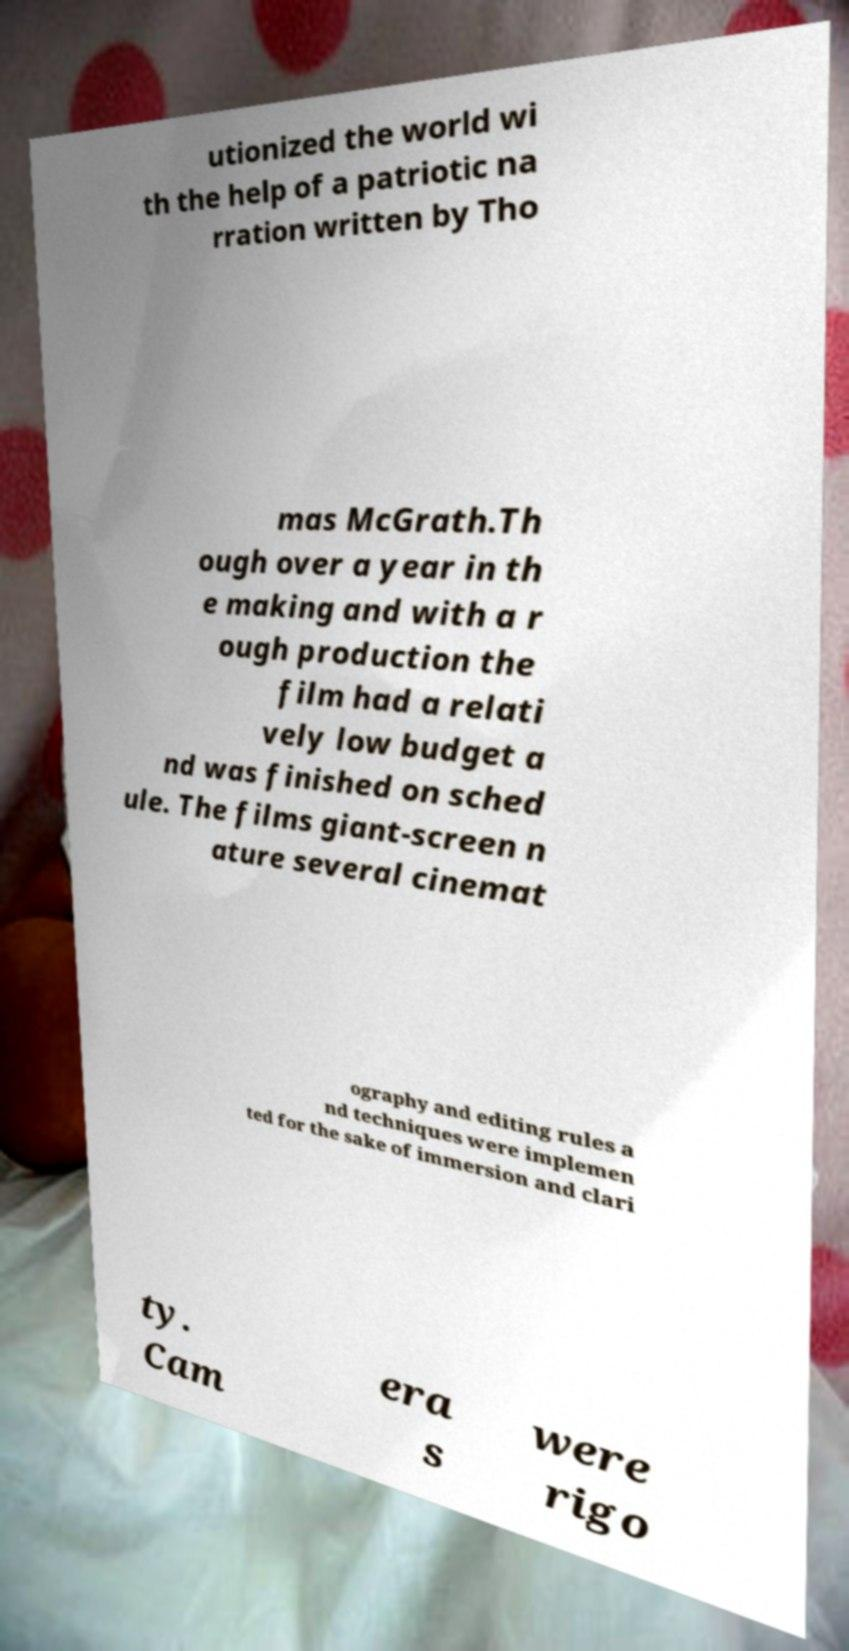I need the written content from this picture converted into text. Can you do that? utionized the world wi th the help of a patriotic na rration written by Tho mas McGrath.Th ough over a year in th e making and with a r ough production the film had a relati vely low budget a nd was finished on sched ule. The films giant-screen n ature several cinemat ography and editing rules a nd techniques were implemen ted for the sake of immersion and clari ty. Cam era s were rigo 